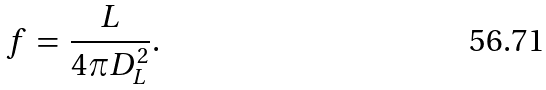<formula> <loc_0><loc_0><loc_500><loc_500>f \, = \, \frac { L } { 4 \pi D _ { L } ^ { 2 } } .</formula> 